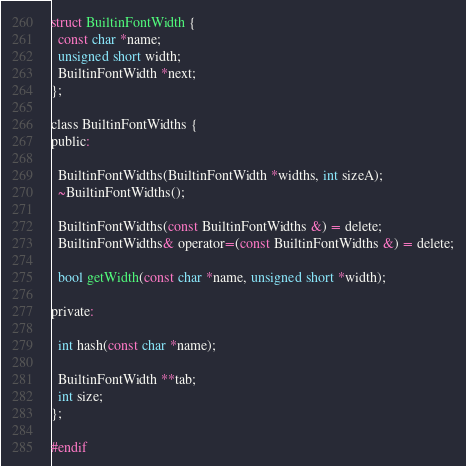<code> <loc_0><loc_0><loc_500><loc_500><_C_>
struct BuiltinFontWidth {
  const char *name;
  unsigned short width;
  BuiltinFontWidth *next;
};

class BuiltinFontWidths {
public:

  BuiltinFontWidths(BuiltinFontWidth *widths, int sizeA);
  ~BuiltinFontWidths();

  BuiltinFontWidths(const BuiltinFontWidths &) = delete;
  BuiltinFontWidths& operator=(const BuiltinFontWidths &) = delete;

  bool getWidth(const char *name, unsigned short *width);

private:

  int hash(const char *name);

  BuiltinFontWidth **tab;
  int size;
};

#endif
</code> 